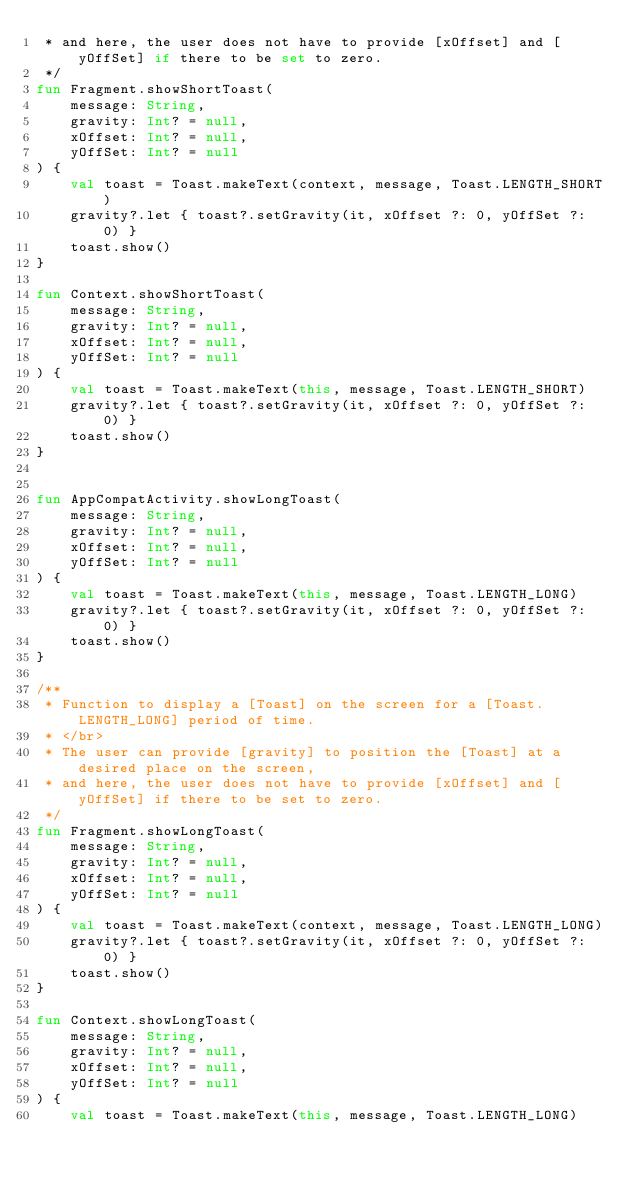Convert code to text. <code><loc_0><loc_0><loc_500><loc_500><_Kotlin_> * and here, the user does not have to provide [xOffset] and [yOffSet] if there to be set to zero.
 */
fun Fragment.showShortToast(
    message: String,
    gravity: Int? = null,
    xOffset: Int? = null,
    yOffSet: Int? = null
) {
    val toast = Toast.makeText(context, message, Toast.LENGTH_SHORT)
    gravity?.let { toast?.setGravity(it, xOffset ?: 0, yOffSet ?: 0) }
    toast.show()
}

fun Context.showShortToast(
    message: String,
    gravity: Int? = null,
    xOffset: Int? = null,
    yOffSet: Int? = null
) {
    val toast = Toast.makeText(this, message, Toast.LENGTH_SHORT)
    gravity?.let { toast?.setGravity(it, xOffset ?: 0, yOffSet ?: 0) }
    toast.show()
}


fun AppCompatActivity.showLongToast(
    message: String,
    gravity: Int? = null,
    xOffset: Int? = null,
    yOffSet: Int? = null
) {
    val toast = Toast.makeText(this, message, Toast.LENGTH_LONG)
    gravity?.let { toast?.setGravity(it, xOffset ?: 0, yOffSet ?: 0) }
    toast.show()
}

/**
 * Function to display a [Toast] on the screen for a [Toast.LENGTH_LONG] period of time.
 * </br>
 * The user can provide [gravity] to position the [Toast] at a desired place on the screen,
 * and here, the user does not have to provide [xOffset] and [yOffSet] if there to be set to zero.
 */
fun Fragment.showLongToast(
    message: String,
    gravity: Int? = null,
    xOffset: Int? = null,
    yOffSet: Int? = null
) {
    val toast = Toast.makeText(context, message, Toast.LENGTH_LONG)
    gravity?.let { toast?.setGravity(it, xOffset ?: 0, yOffSet ?: 0) }
    toast.show()
}

fun Context.showLongToast(
    message: String,
    gravity: Int? = null,
    xOffset: Int? = null,
    yOffSet: Int? = null
) {
    val toast = Toast.makeText(this, message, Toast.LENGTH_LONG)</code> 